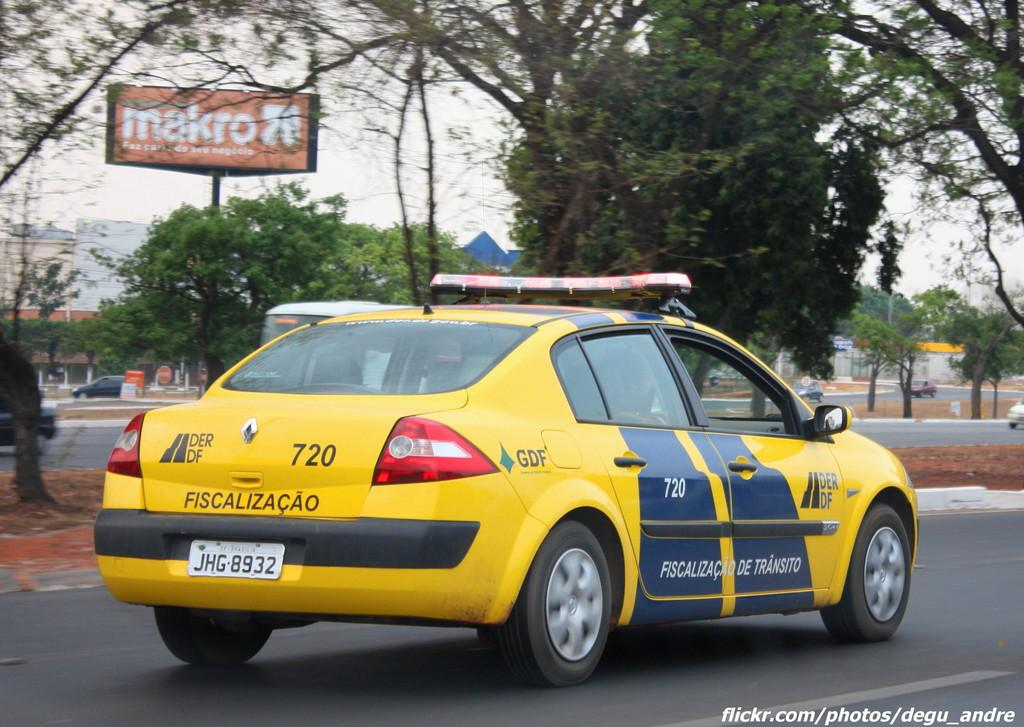Provide a one-sentence caption for the provided image. a transit prosecutor car with the number 720. 